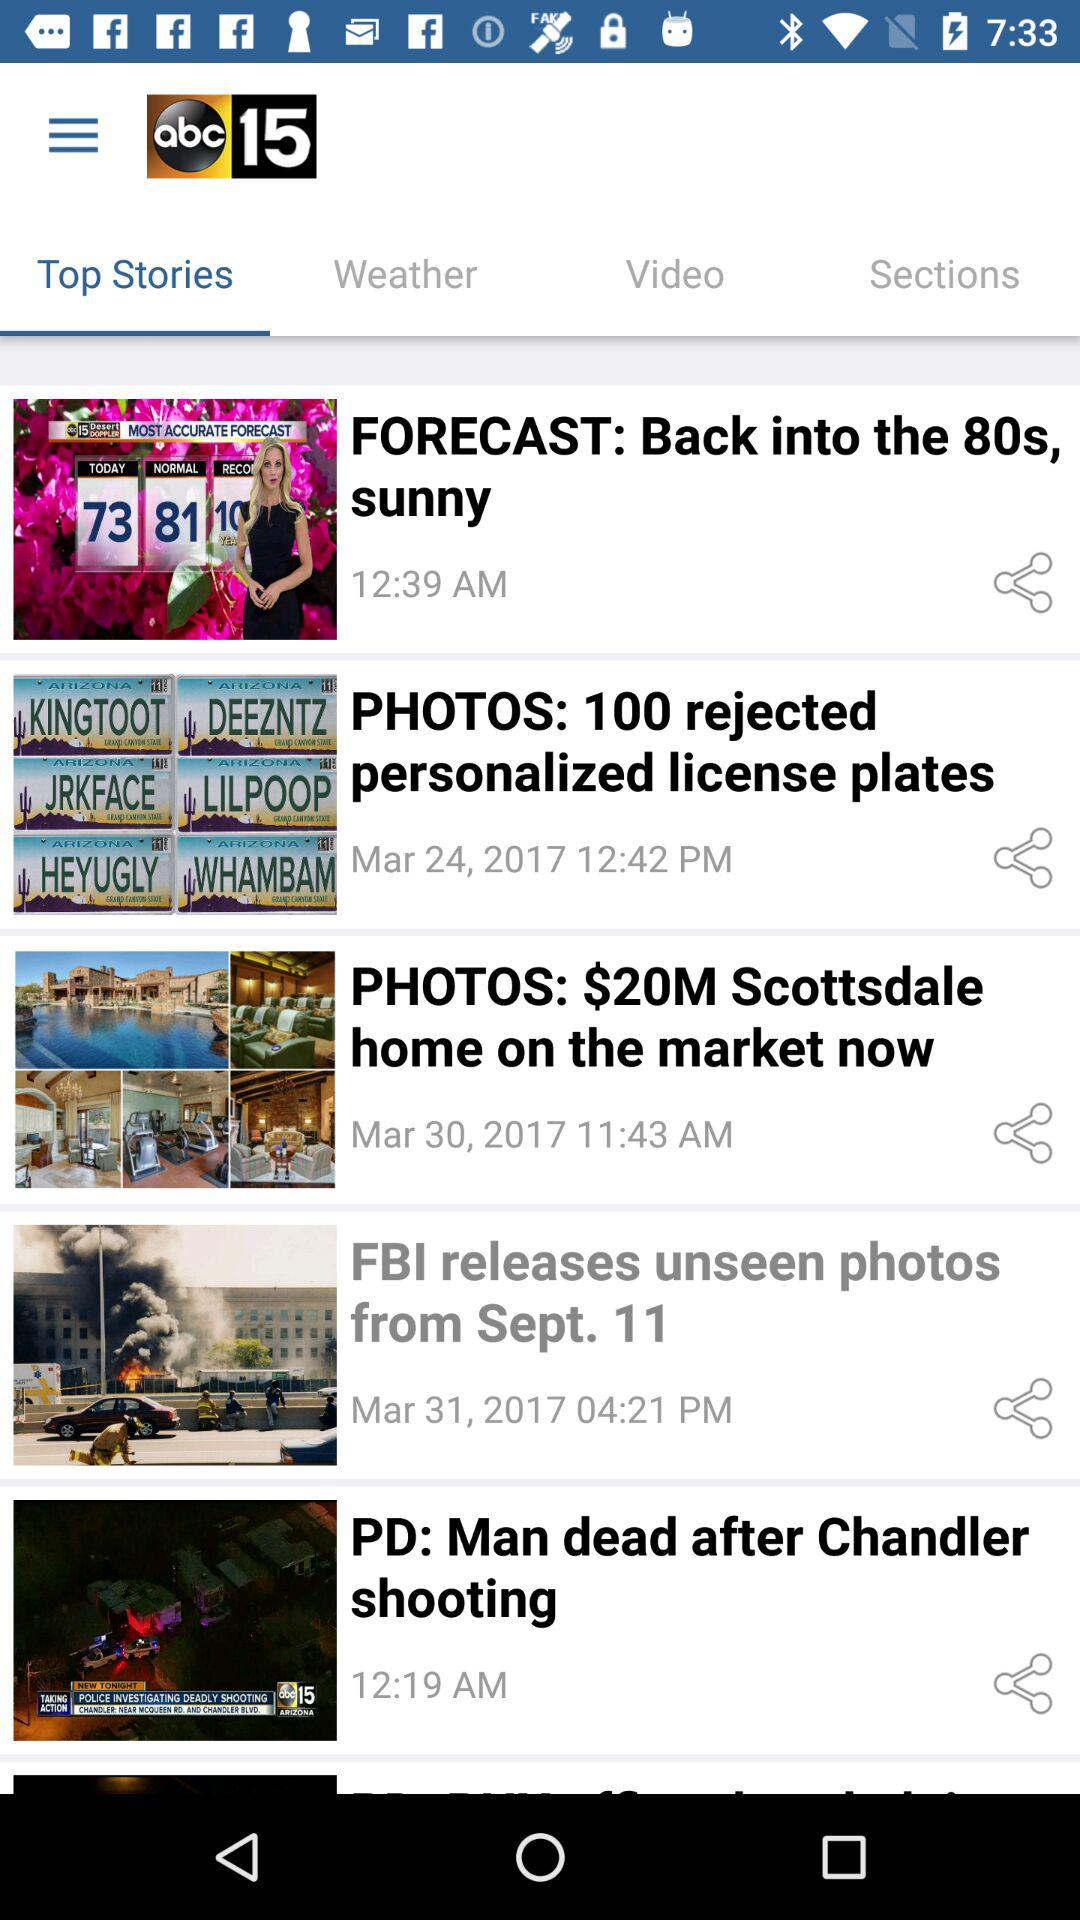On what day "PHOTOS: $20M Scottsdale home on the market now" story posted? The day is Mar 24, 2017. 